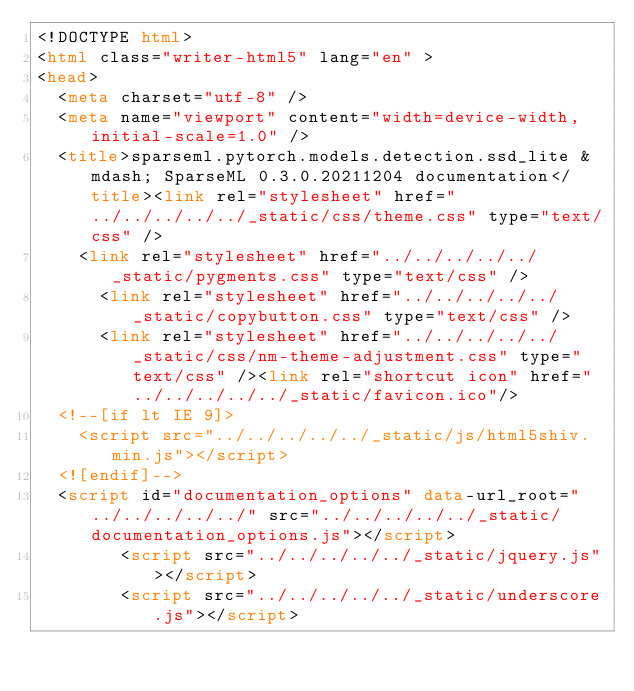Convert code to text. <code><loc_0><loc_0><loc_500><loc_500><_HTML_><!DOCTYPE html>
<html class="writer-html5" lang="en" >
<head>
  <meta charset="utf-8" />
  <meta name="viewport" content="width=device-width, initial-scale=1.0" />
  <title>sparseml.pytorch.models.detection.ssd_lite &mdash; SparseML 0.3.0.20211204 documentation</title><link rel="stylesheet" href="../../../../../_static/css/theme.css" type="text/css" />
    <link rel="stylesheet" href="../../../../../_static/pygments.css" type="text/css" />
      <link rel="stylesheet" href="../../../../../_static/copybutton.css" type="text/css" />
      <link rel="stylesheet" href="../../../../../_static/css/nm-theme-adjustment.css" type="text/css" /><link rel="shortcut icon" href="../../../../../_static/favicon.ico"/>
  <!--[if lt IE 9]>
    <script src="../../../../../_static/js/html5shiv.min.js"></script>
  <![endif]-->
  <script id="documentation_options" data-url_root="../../../../../" src="../../../../../_static/documentation_options.js"></script>
        <script src="../../../../../_static/jquery.js"></script>
        <script src="../../../../../_static/underscore.js"></script></code> 